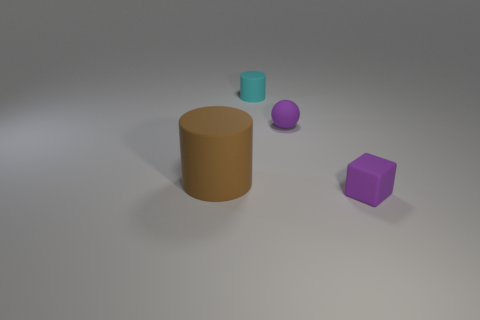Is there anything else that has the same size as the brown rubber cylinder?
Offer a terse response. No. Do the rubber ball on the left side of the small purple cube and the rubber block have the same color?
Your response must be concise. Yes. What material is the object that is to the left of the purple matte ball and behind the brown matte cylinder?
Keep it short and to the point. Rubber. Are there any purple matte things of the same size as the ball?
Keep it short and to the point. Yes. How many small purple rubber things are there?
Make the answer very short. 2. What number of purple rubber things are in front of the purple ball?
Keep it short and to the point. 1. Does the small cube have the same material as the big brown object?
Your answer should be compact. Yes. How many matte cylinders are both behind the large cylinder and in front of the purple sphere?
Your answer should be compact. 0. What number of other objects are there of the same color as the tiny sphere?
Ensure brevity in your answer.  1. How many cyan objects are either cubes or small matte things?
Your response must be concise. 1. 